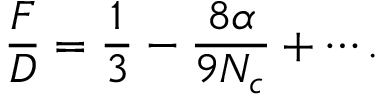Convert formula to latex. <formula><loc_0><loc_0><loc_500><loc_500>\frac { F } { D } = \frac { 1 } { 3 } - \frac { 8 \alpha } { 9 N _ { c } } + \cdots .</formula> 